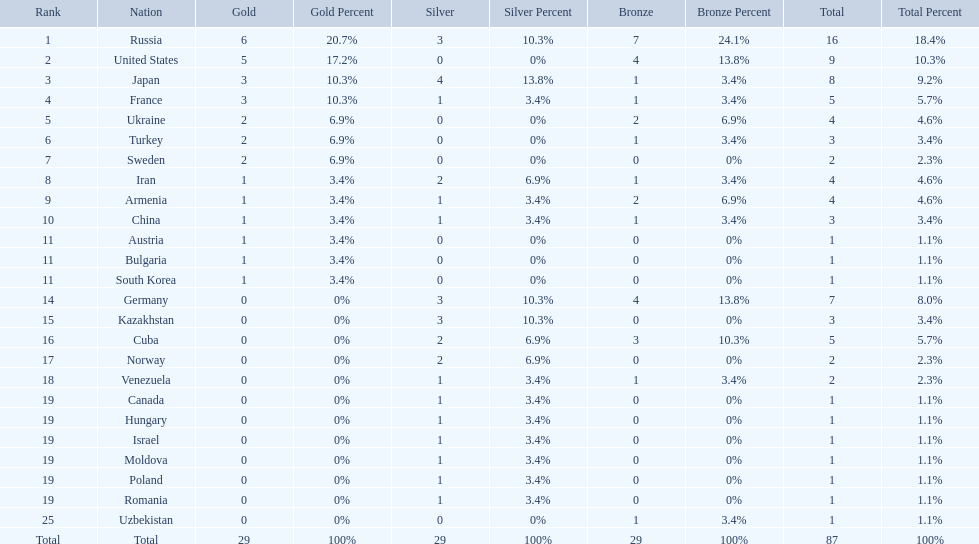Which nations only won less then 5 medals? Ukraine, Turkey, Sweden, Iran, Armenia, China, Austria, Bulgaria, South Korea, Germany, Kazakhstan, Norway, Venezuela, Canada, Hungary, Israel, Moldova, Poland, Romania, Uzbekistan. Which of these were not asian nations? Ukraine, Turkey, Sweden, Iran, Armenia, Austria, Bulgaria, Germany, Kazakhstan, Norway, Venezuela, Canada, Hungary, Israel, Moldova, Poland, Romania, Uzbekistan. Which of those did not win any silver medals? Ukraine, Turkey, Sweden, Austria, Bulgaria, Uzbekistan. Which ones of these had only one medal total? Austria, Bulgaria, Uzbekistan. Which of those would be listed first alphabetically? Austria. 